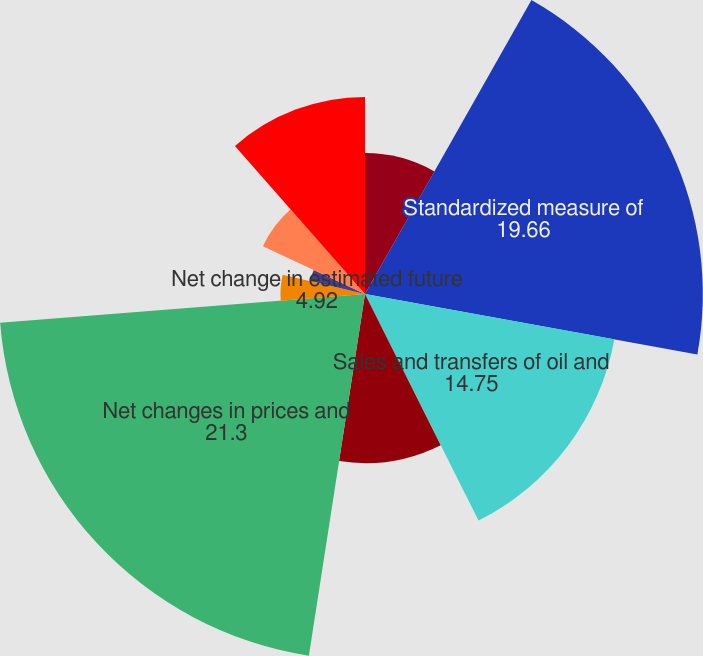Convert chart to OTSL. <chart><loc_0><loc_0><loc_500><loc_500><pie_chart><fcel>For the Years Ended December<fcel>Standardized measure of<fcel>Sales and transfers of oil and<fcel>Development costs incurred<fcel>Net changes in prices and<fcel>Net change in estimated future<fcel>Extensions and discoveries<fcel>Revisions of previous oil and<fcel>Net purchases (sales) of<fcel>Accretion of discount<nl><fcel>8.2%<fcel>19.66%<fcel>14.75%<fcel>9.84%<fcel>21.3%<fcel>4.92%<fcel>3.29%<fcel>6.56%<fcel>0.01%<fcel>11.47%<nl></chart> 